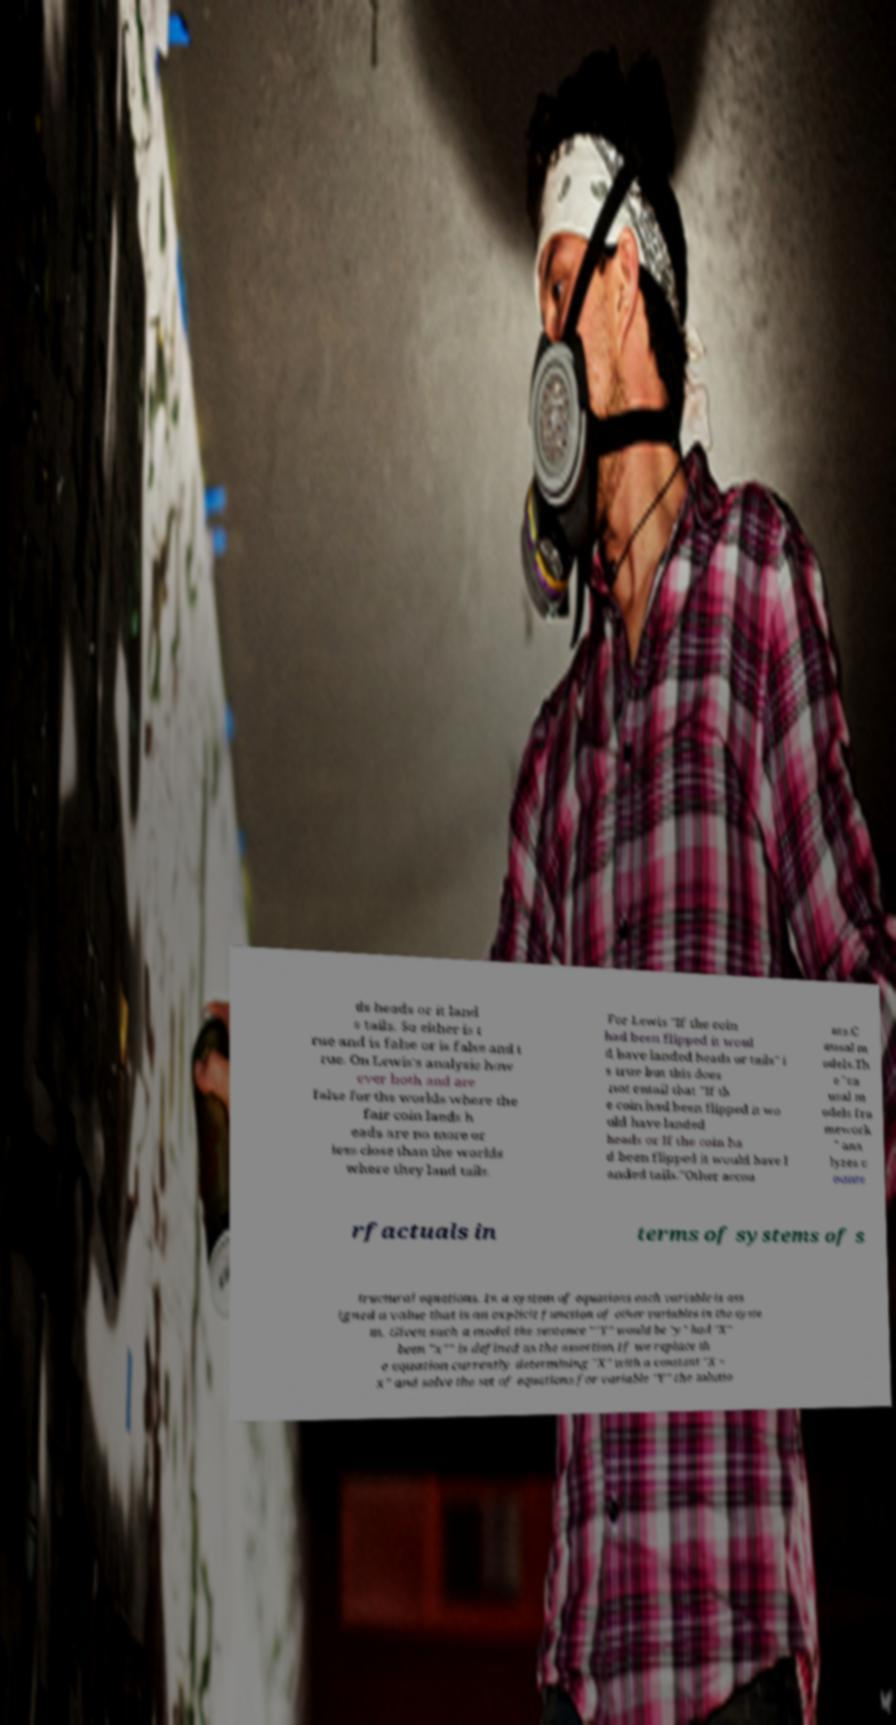Can you accurately transcribe the text from the provided image for me? ds heads or it land s tails. So either is t rue and is false or is false and t rue. On Lewis's analysis how ever both and are false for the worlds where the fair coin lands h eads are no more or less close than the worlds where they land tails. For Lewis "If the coin had been flipped it woul d have landed heads or tails" i s true but this does not entail that "If th e coin had been flipped it wo uld have landed heads or If the coin ha d been flipped it would have l anded tails."Other accou nts.C ausal m odels.Th e "ca usal m odels fra mework " ana lyzes c ounte rfactuals in terms of systems of s tructural equations. In a system of equations each variable is ass igned a value that is an explicit function of other variables in the syste m. Given such a model the sentence ""Y" would be "y" had "X" been "x"" is defined as the assertion If we replace th e equation currently determining "X" with a constant "X = x" and solve the set of equations for variable "Y" the solutio 